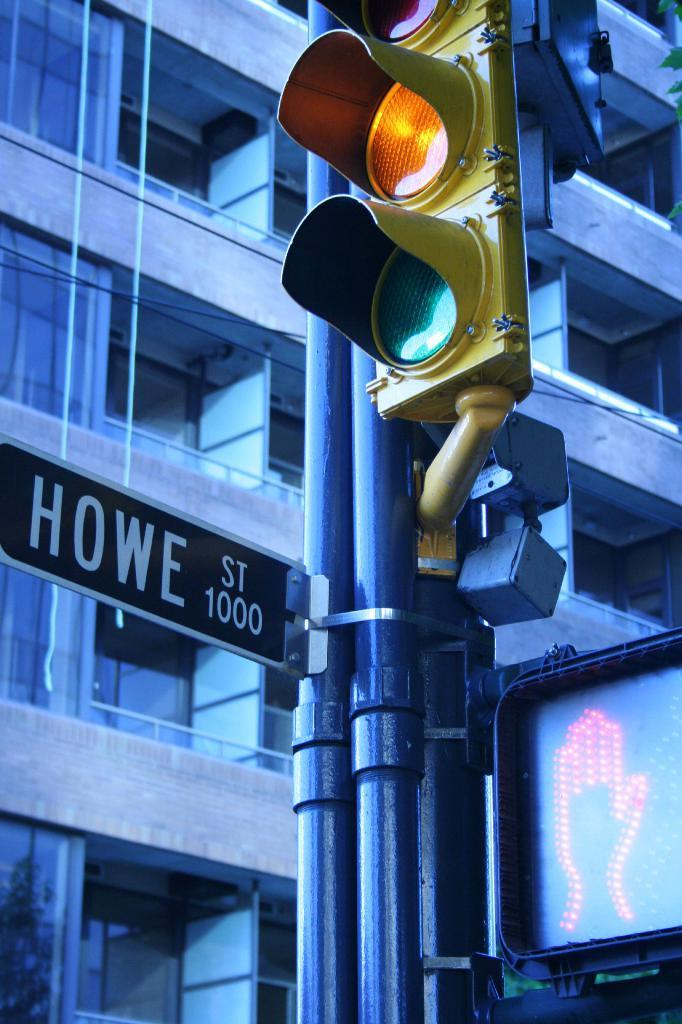<image>
Write a terse but informative summary of the picture. A traffic light turns yellow on Howe Street. 